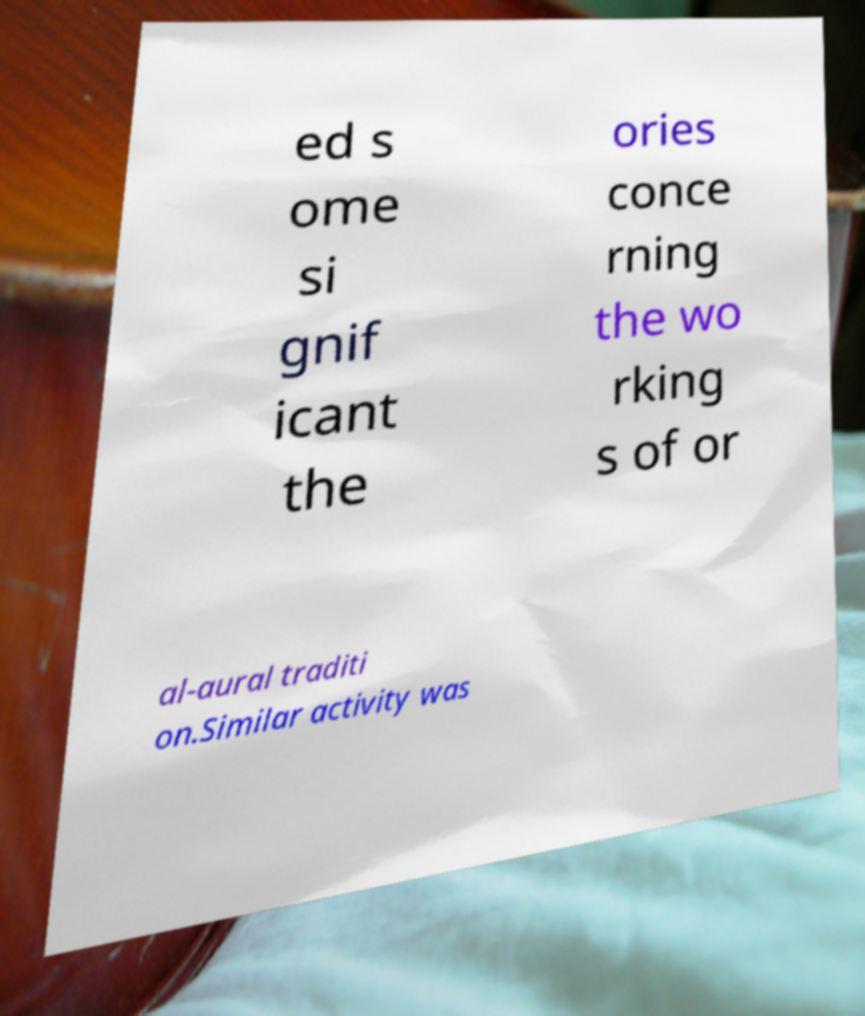Please read and relay the text visible in this image. What does it say? ed s ome si gnif icant the ories conce rning the wo rking s of or al-aural traditi on.Similar activity was 